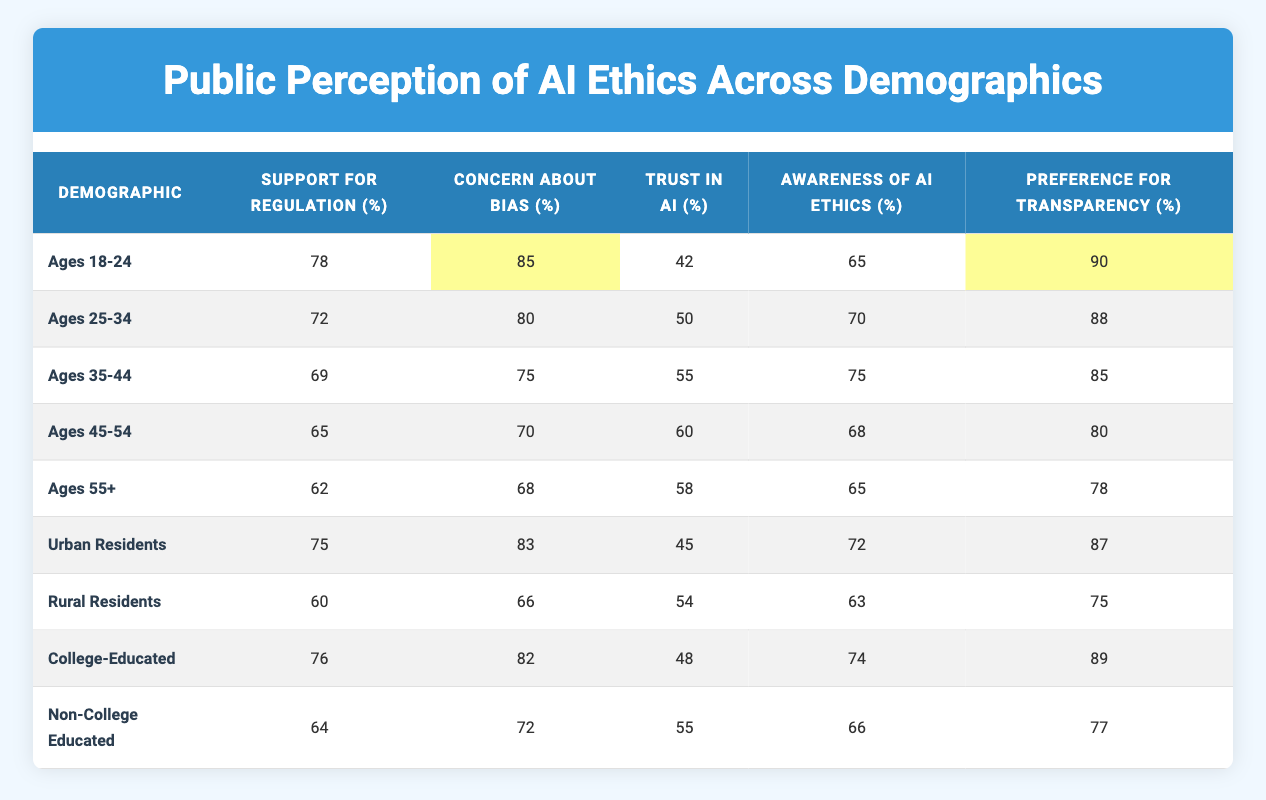What percentage of the "Ages 18-24" demographic supports regulation? In the table, under the "Ages 18-24" row, the column labeled "Support for Regulation (%)" shows the value 78.
Answer: 78 Which demographic shows the highest concern about bias in AI? Looking at the "Concern About Bias (%)" column, the highest value is 85, which corresponds to the "Ages 18-24" demographic.
Answer: Ages 18-24 What is the average trust in AI across all demographics listed? To find the average trust in AI, add all the trust values (42, 50, 55, 60, 58, 45, 54, 55), which equals 419. There are 8 demographics, so the average is 419/8 = 52.375.
Answer: 52.375 Is there a significant difference in the support for regulation between Urban Residents and Rural Residents? Urban Residents have a support for regulation of 75%, while Rural Residents have 60%. The difference is 75 - 60 = 15%, which indicates a significant difference.
Answer: Yes What demographic has the lowest preference for transparency? The "Preference for Transparency (%)" column indicates that "Ages 55+" has the lowest value of 78.
Answer: Ages 55+ How many demographics have a trust in AI percentage greater than 50? The trust values greater than 50 are from the "Ages 35-44", "Ages 45-54", and "College-Educated" demographics. That makes 3 demographics with trust greater than 50.
Answer: 3 What is the difference in awareness of AI ethics between the youngest age group and the oldest age group? The "Ages 18-24" demographic has an awareness of 65%, while the "Ages 55+" demographic has 65%. The difference is 65 - 65 = 0%.
Answer: 0% How does the concern about bias compare between College-Educated and Non-College Educated demographics? College-Educated have a concern about bias of 82%, while Non-College Educated have 72%. The difference is 82 - 72 = 10%, indicating College-Educated have higher concern about bias.
Answer: College-Educated have higher concern What is the preference for transparency among the "Ages 45-54"? Under the "Ages 45-54" demographic, the preference for transparency is 80%, as listed in the table.
Answer: 80% 